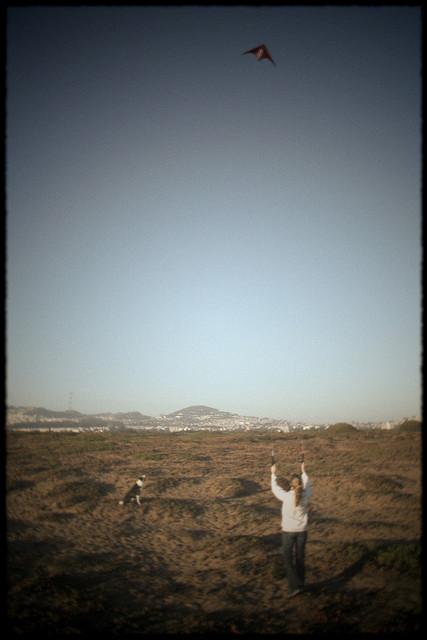Is the woman wearing pants?
Write a very short answer. Yes. What is the person doing?
Answer briefly. Flying kite. What are they doing?
Give a very brief answer. Flying kite. How many dogs are seen?
Answer briefly. 1. Is she waving at a bird?
Short answer required. No. What season is it?
Answer briefly. Fall. How many people are there?
Keep it brief. 1. Is the sky cloudy?
Be succinct. No. Is the dog wearing something?
Quick response, please. No. Is he in the air?
Answer briefly. No. Is that grass green?
Concise answer only. No. Are there power lines in the background?
Be succinct. No. In what type of environment does the bird live?
Short answer required. Desert. Is there an animal in this photo?
Give a very brief answer. Yes. Is there a dog waiting at the door?
Be succinct. No. What is covering the ground?
Concise answer only. Grass. Is this a skate park?
Short answer required. No. What color is the grass?
Concise answer only. Brown. Is he practicing a dangerous sport?
Concise answer only. No. Is this picture taken at sea level?
Concise answer only. No. What is this person doing?
Give a very brief answer. Flying kite. 